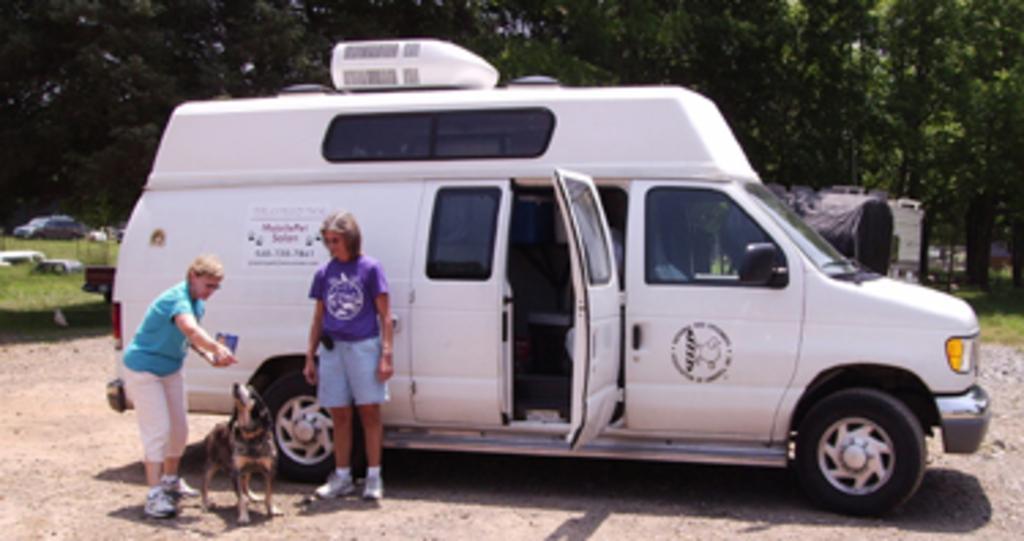Can you describe this image briefly? In this image I can see two people standing on the ground. I can also see the dog to the side. These are to the side of the white color vehicle. In the background I can see few more vehicles and many trees. These people are wearing the different color dresses. 